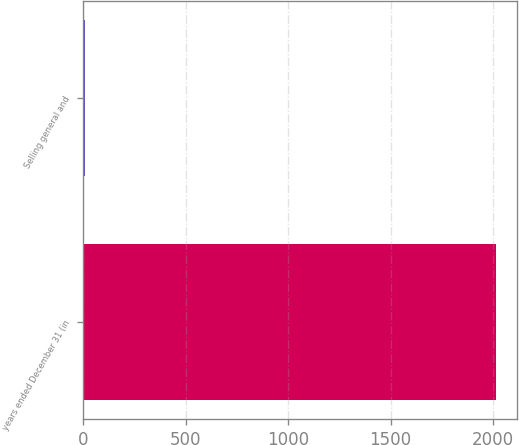<chart> <loc_0><loc_0><loc_500><loc_500><bar_chart><fcel>years ended December 31 (in<fcel>Selling general and<nl><fcel>2016<fcel>8<nl></chart> 